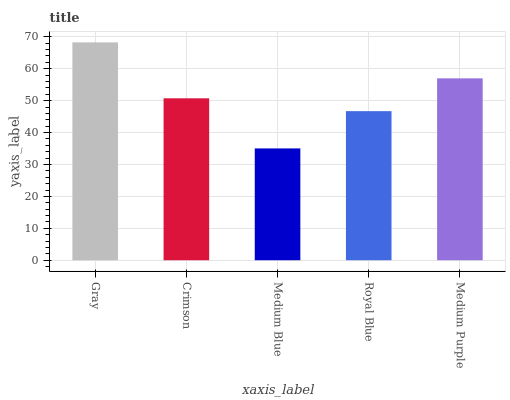Is Medium Blue the minimum?
Answer yes or no. Yes. Is Gray the maximum?
Answer yes or no. Yes. Is Crimson the minimum?
Answer yes or no. No. Is Crimson the maximum?
Answer yes or no. No. Is Gray greater than Crimson?
Answer yes or no. Yes. Is Crimson less than Gray?
Answer yes or no. Yes. Is Crimson greater than Gray?
Answer yes or no. No. Is Gray less than Crimson?
Answer yes or no. No. Is Crimson the high median?
Answer yes or no. Yes. Is Crimson the low median?
Answer yes or no. Yes. Is Medium Purple the high median?
Answer yes or no. No. Is Medium Blue the low median?
Answer yes or no. No. 